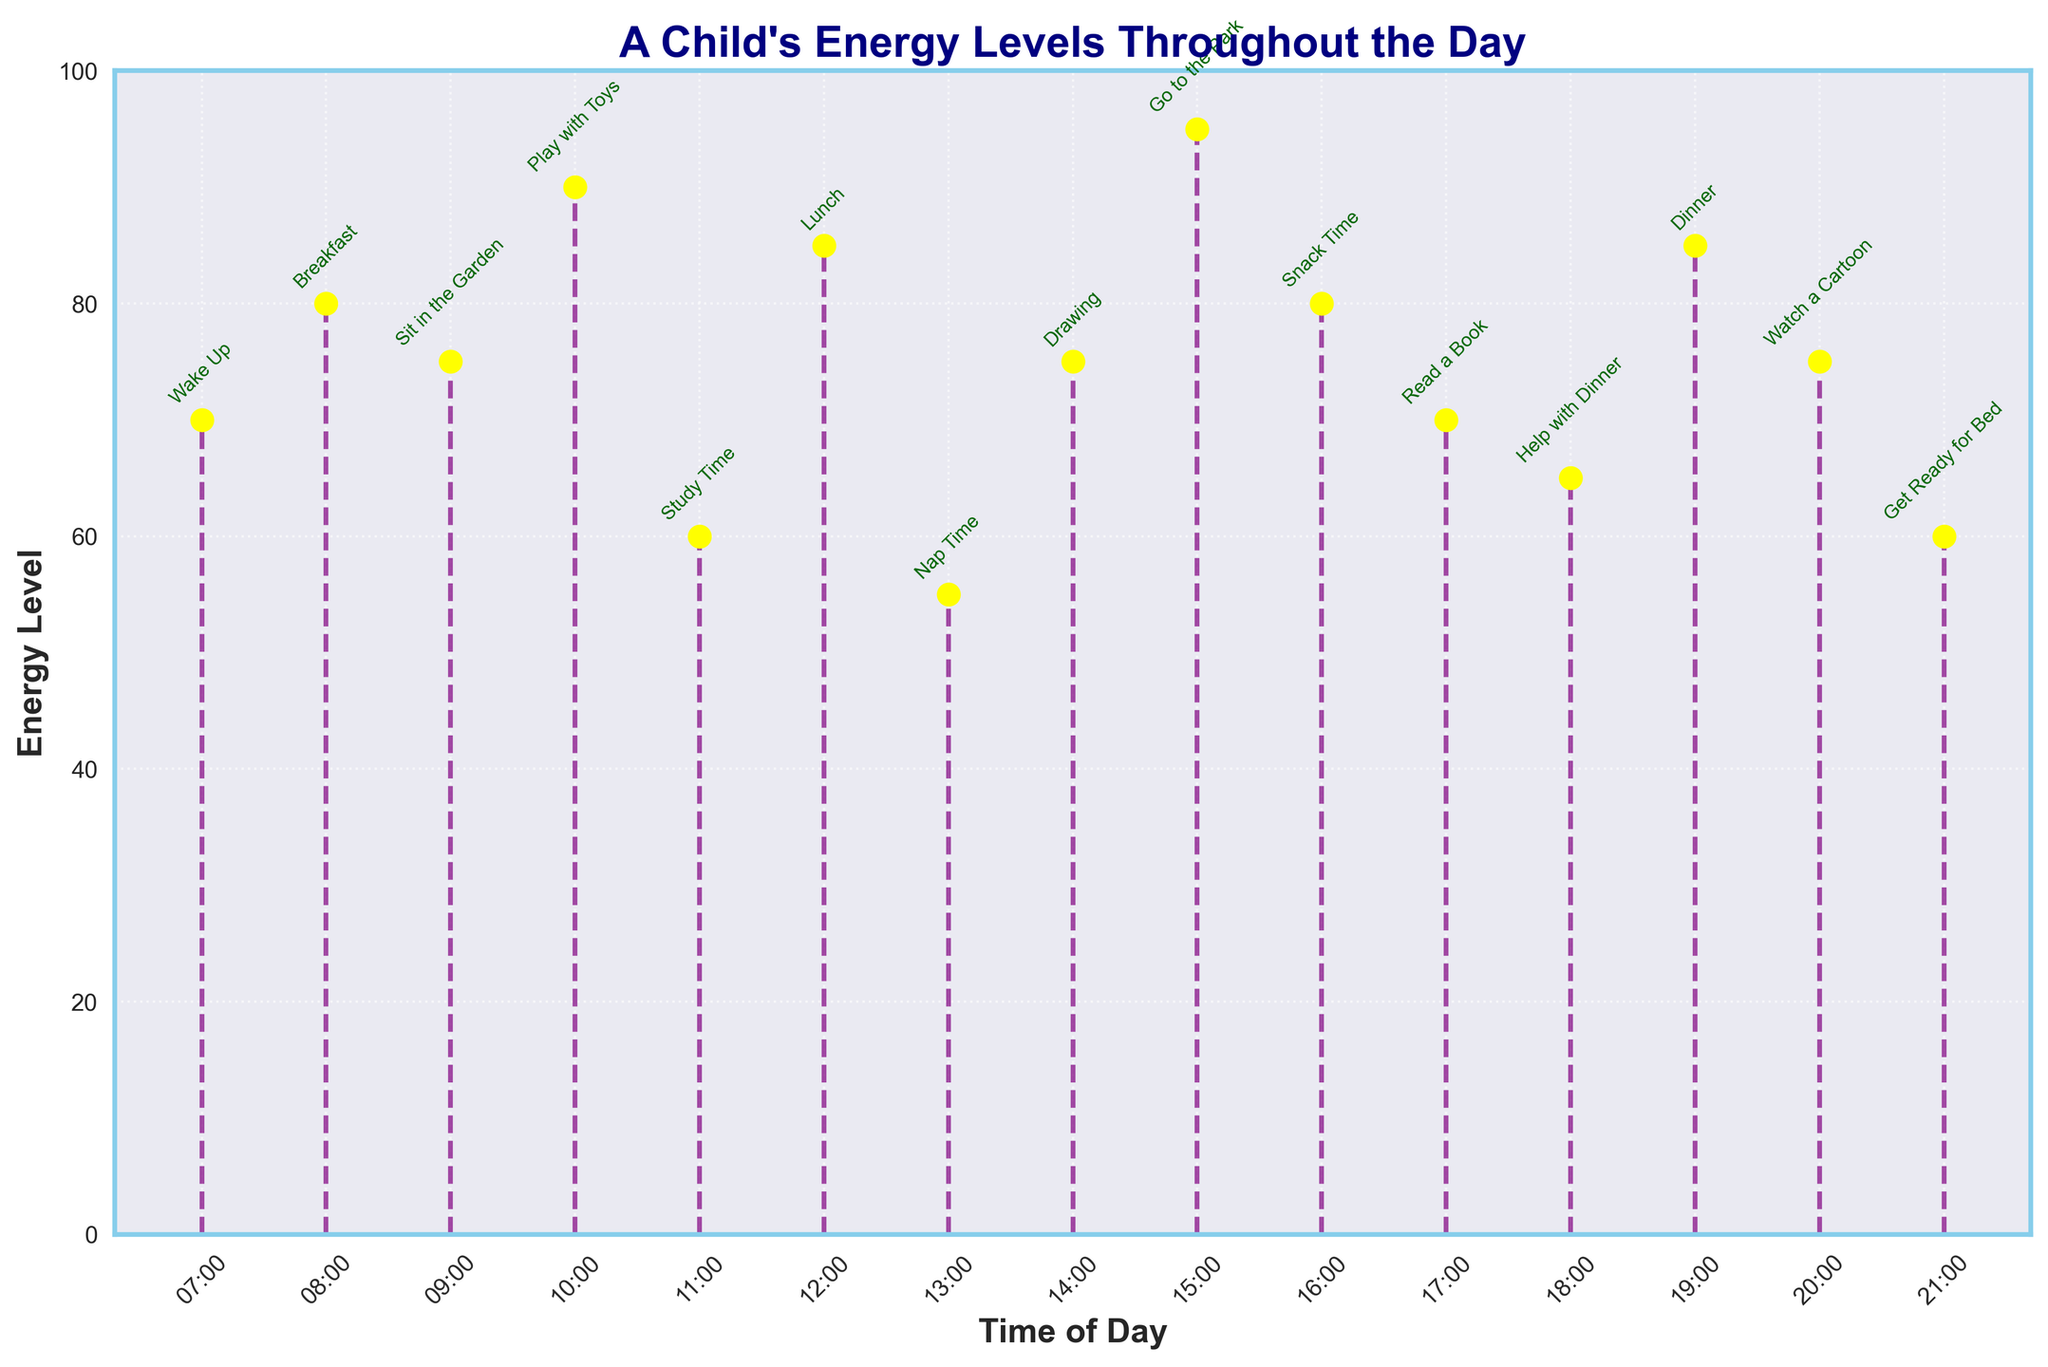What is the title of the figure? The title of the figure is usually located at the top and is in bold. The title reads, "A Child's Energy Levels Throughout the Day".
Answer: A Child's Energy Levels Throughout the Day What are the labels of the x-axis and y-axis? The x-axis label is at the bottom of the chart, and the y-axis label is along the left side. The labels read "Time of Day" and "Energy Level", respectively.
Answer: Time of Day and Energy Level How many data points are shown in the figure? Each stem on the plot represents a data point, and there are 15 distinct points starting from 07:00 to 21:00.
Answer: 15 During which activity is the energy level the highest? This can be determined by finding the highest point on the y-axis. The highest energy level is 95, observed during the activity "Go to the Park".
Answer: Go to the Park What is the energy level at 10:00? Locate the 10:00 mark on the x-axis and check the corresponding energy level on the y-axis. It shows 90.
Answer: 90 What is the average energy level between 08:00 and 12:00? Sum the energy levels at 08:00, 09:00, 10:00, 11:00, and 12:00: (80 + 75 + 90 + 60 + 85) = 390. Divide by 5 to get the average: 390 / 5 = 78.
Answer: 78 Which activity has the lowest energy level, and what is that level? Look for the lowest point on the y-axis. The lowest energy level is 55, observed during "Nap Time".
Answer: Nap Time, 55 How does the energy level change between 07:00 and 08:00? Compare the energy level at 07:00 (70) with that at 08:00 (80). The energy level increases by 10 units.
Answer: Increases by 10 Compare the energy level at 13:00 with the level at 17:00. Check the energy levels at 13:00 (55) and 17:00 (70). The energy level at 17:00 is higher than at 13:00 by 15 units.
Answer: 17:00 is higher by 15 What is the overall trend in energy levels throughout the day? Analyze the general direction of the energy levels from morning to evening. There are fluctuations, but the energy generally peaks in the afternoon with higher levels during active times and lowers during rest times.
Answer: Fluctuates with peaks and troughs 